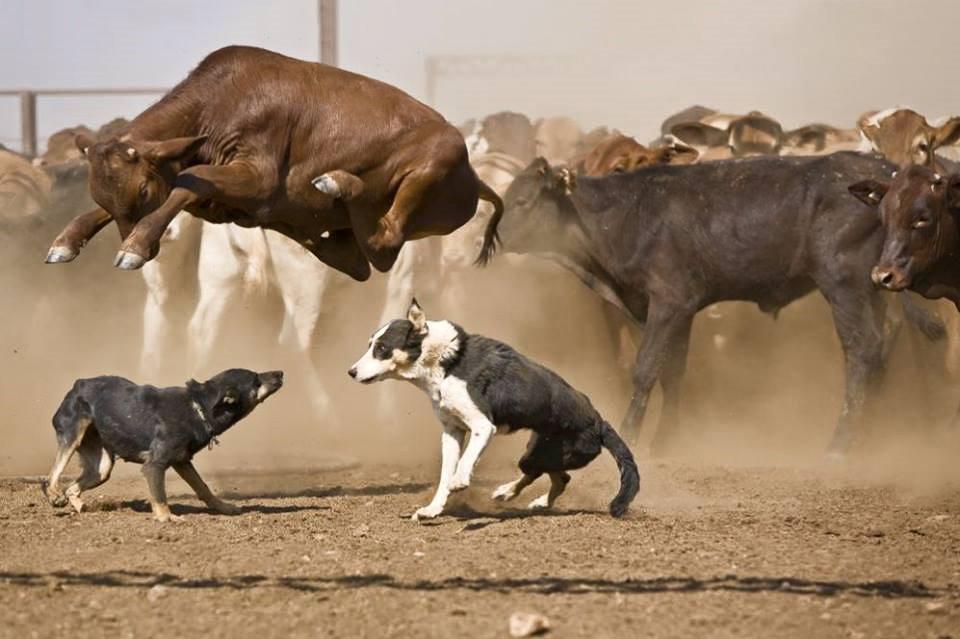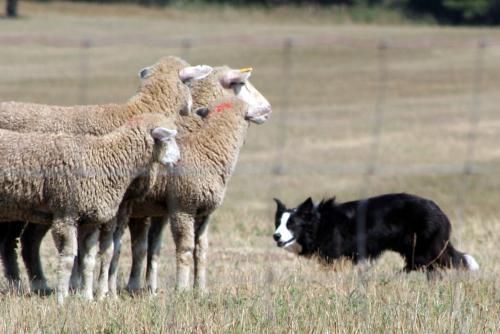The first image is the image on the left, the second image is the image on the right. For the images shown, is this caption "One image contains a sheep dog herding three or more sheep." true? Answer yes or no. Yes. The first image is the image on the left, the second image is the image on the right. For the images shown, is this caption "Left and right images each show a black-and-white dog in front of multiple standing cattle." true? Answer yes or no. No. 